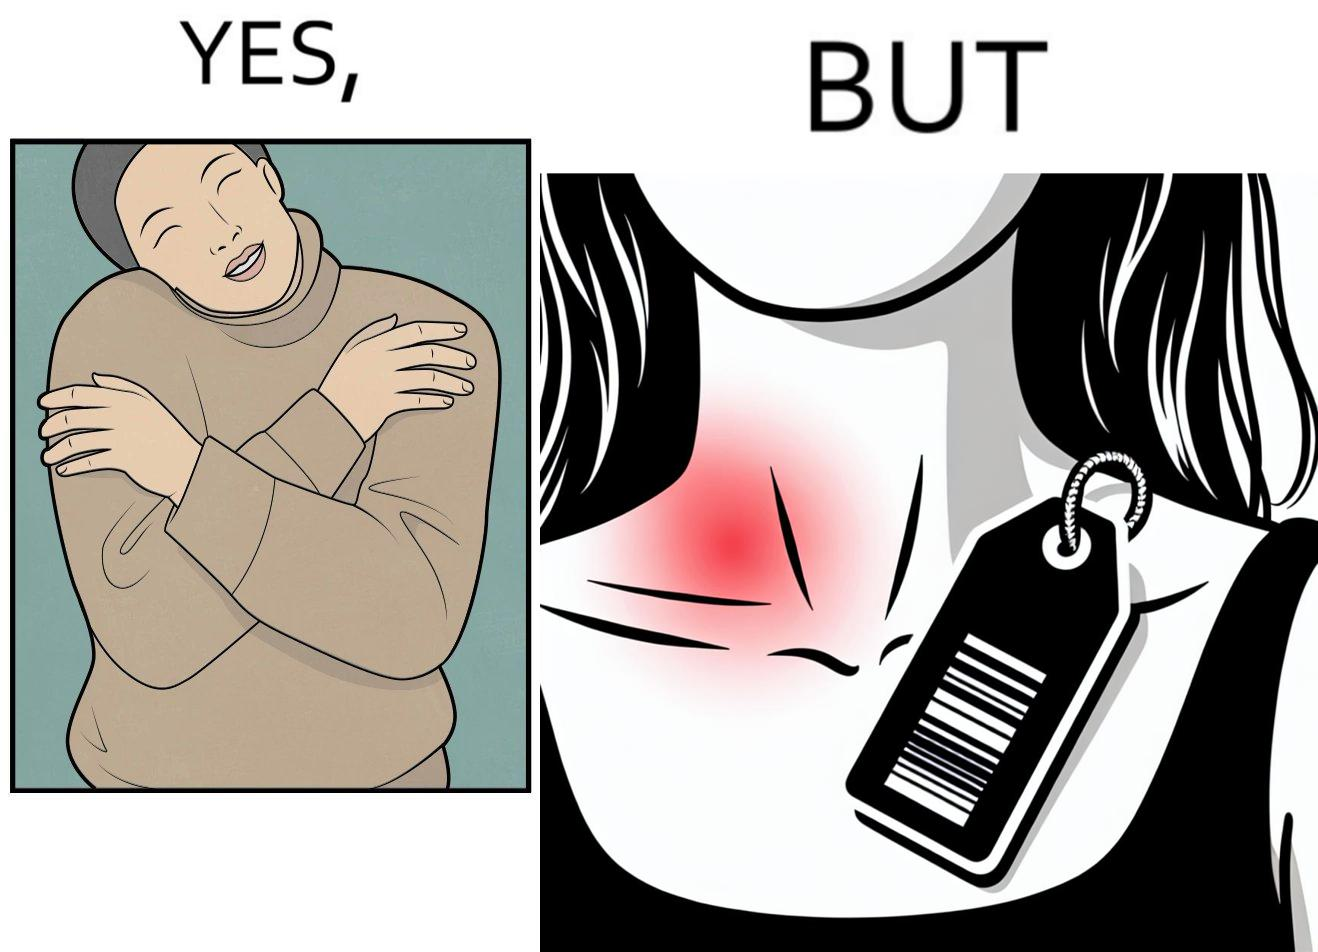Would you classify this image as satirical? Yes, this image is satirical. 